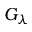<formula> <loc_0><loc_0><loc_500><loc_500>G _ { \lambda }</formula> 